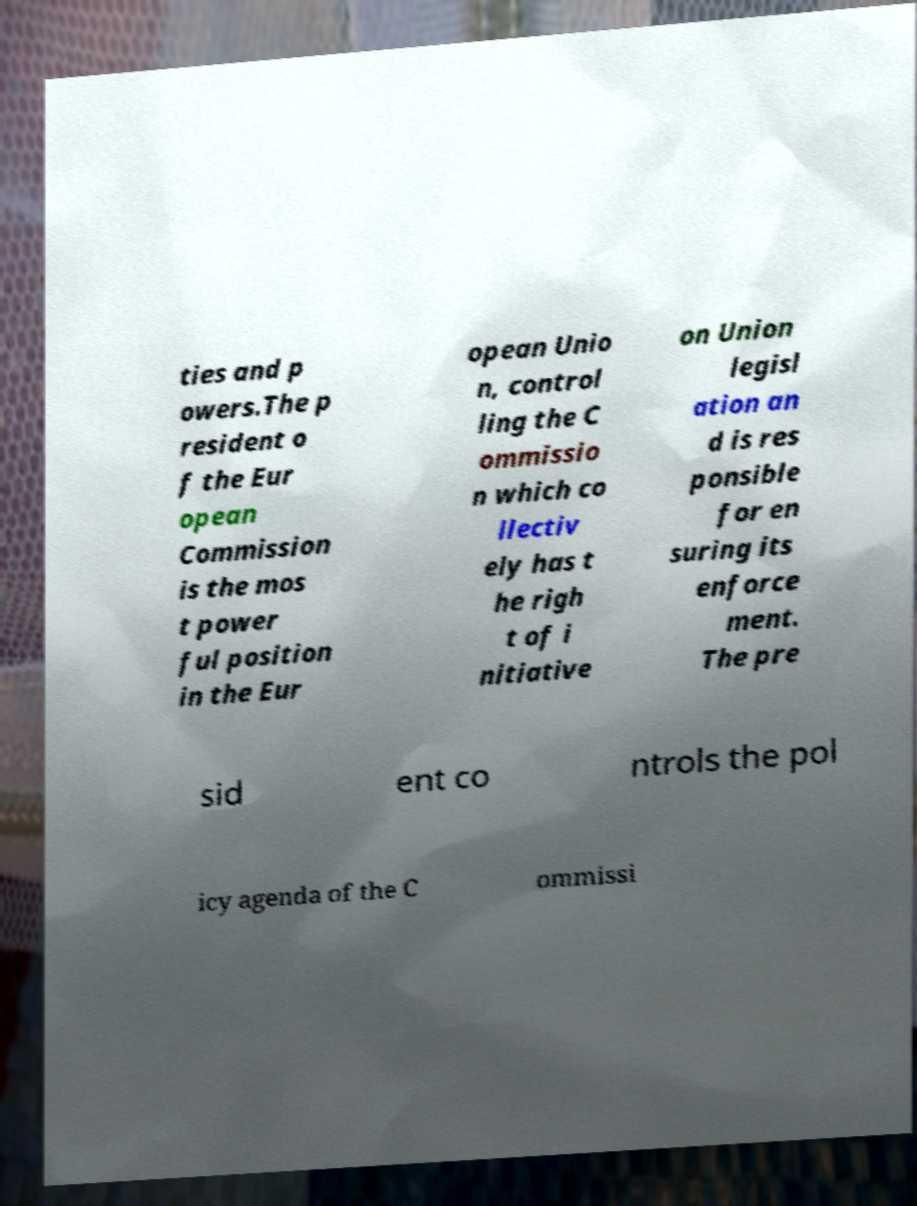Please identify and transcribe the text found in this image. ties and p owers.The p resident o f the Eur opean Commission is the mos t power ful position in the Eur opean Unio n, control ling the C ommissio n which co llectiv ely has t he righ t of i nitiative on Union legisl ation an d is res ponsible for en suring its enforce ment. The pre sid ent co ntrols the pol icy agenda of the C ommissi 